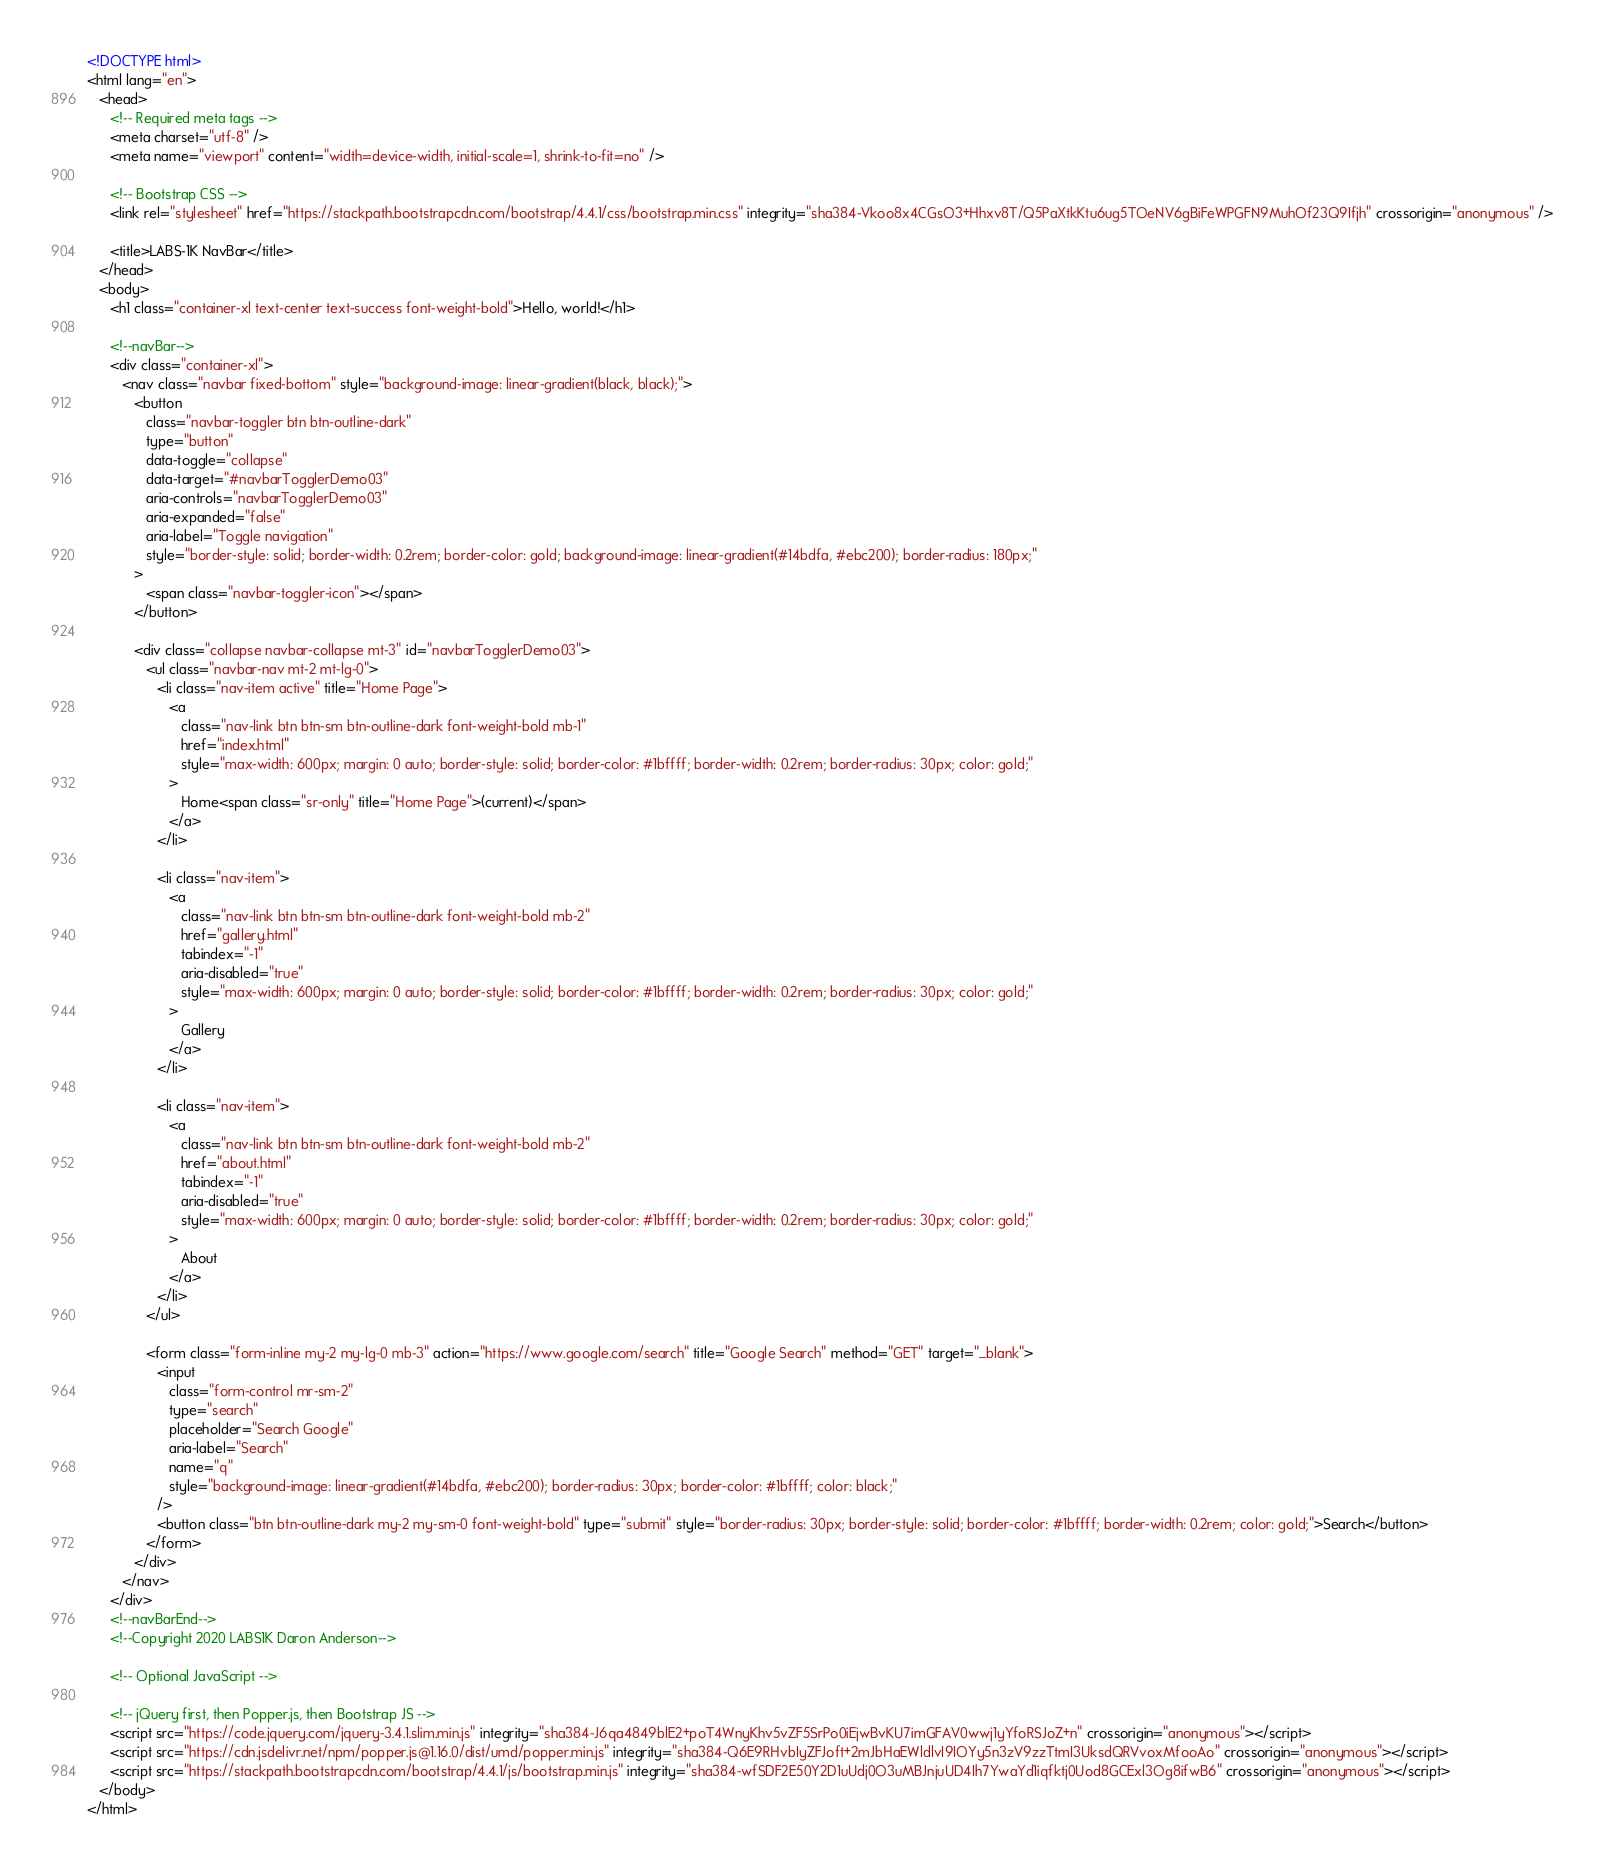Convert code to text. <code><loc_0><loc_0><loc_500><loc_500><_HTML_><!DOCTYPE html>
<html lang="en">
   <head>
      <!-- Required meta tags -->
      <meta charset="utf-8" />
      <meta name="viewport" content="width=device-width, initial-scale=1, shrink-to-fit=no" />

      <!-- Bootstrap CSS -->
      <link rel="stylesheet" href="https://stackpath.bootstrapcdn.com/bootstrap/4.4.1/css/bootstrap.min.css" integrity="sha384-Vkoo8x4CGsO3+Hhxv8T/Q5PaXtkKtu6ug5TOeNV6gBiFeWPGFN9MuhOf23Q9Ifjh" crossorigin="anonymous" />

      <title>LABS-1K NavBar</title>
   </head>
   <body>
      <h1 class="container-xl text-center text-success font-weight-bold">Hello, world!</h1>

      <!--navBar-->
      <div class="container-xl">
         <nav class="navbar fixed-bottom" style="background-image: linear-gradient(black, black);">
            <button
               class="navbar-toggler btn btn-outline-dark"
               type="button"
               data-toggle="collapse"
               data-target="#navbarTogglerDemo03"
               aria-controls="navbarTogglerDemo03"
               aria-expanded="false"
               aria-label="Toggle navigation"
               style="border-style: solid; border-width: 0.2rem; border-color: gold; background-image: linear-gradient(#14bdfa, #ebc200); border-radius: 180px;"
            >
               <span class="navbar-toggler-icon"></span>
            </button>

            <div class="collapse navbar-collapse mt-3" id="navbarTogglerDemo03">
               <ul class="navbar-nav mt-2 mt-lg-0">
                  <li class="nav-item active" title="Home Page">
                     <a
                        class="nav-link btn btn-sm btn-outline-dark font-weight-bold mb-1"
                        href="index.html"
                        style="max-width: 600px; margin: 0 auto; border-style: solid; border-color: #1bffff; border-width: 0.2rem; border-radius: 30px; color: gold;"
                     >
                        Home<span class="sr-only" title="Home Page">(current)</span>
                     </a>
                  </li>

                  <li class="nav-item">
                     <a
                        class="nav-link btn btn-sm btn-outline-dark font-weight-bold mb-2"
                        href="gallery.html"
                        tabindex="-1"
                        aria-disabled="true"
                        style="max-width: 600px; margin: 0 auto; border-style: solid; border-color: #1bffff; border-width: 0.2rem; border-radius: 30px; color: gold;"
                     >
                        Gallery
                     </a>
                  </li>

                  <li class="nav-item">
                     <a
                        class="nav-link btn btn-sm btn-outline-dark font-weight-bold mb-2"
                        href="about.html"
                        tabindex="-1"
                        aria-disabled="true"
                        style="max-width: 600px; margin: 0 auto; border-style: solid; border-color: #1bffff; border-width: 0.2rem; border-radius: 30px; color: gold;"
                     >
                        About
                     </a>
                  </li>
               </ul>

               <form class="form-inline my-2 my-lg-0 mb-3" action="https://www.google.com/search" title="Google Search" method="GET" target="_blank">
                  <input
                     class="form-control mr-sm-2"
                     type="search"
                     placeholder="Search Google"
                     aria-label="Search"
                     name="q"
                     style="background-image: linear-gradient(#14bdfa, #ebc200); border-radius: 30px; border-color: #1bffff; color: black;"
                  />
                  <button class="btn btn-outline-dark my-2 my-sm-0 font-weight-bold" type="submit" style="border-radius: 30px; border-style: solid; border-color: #1bffff; border-width: 0.2rem; color: gold;">Search</button>
               </form>
            </div>
         </nav>
      </div>
      <!--navBarEnd-->
      <!--Copyright 2020 LABS1K Daron Anderson-->

      <!-- Optional JavaScript -->
         
      <!-- jQuery first, then Popper.js, then Bootstrap JS -->
      <script src="https://code.jquery.com/jquery-3.4.1.slim.min.js" integrity="sha384-J6qa4849blE2+poT4WnyKhv5vZF5SrPo0iEjwBvKU7imGFAV0wwj1yYfoRSJoZ+n" crossorigin="anonymous"></script>
      <script src="https://cdn.jsdelivr.net/npm/popper.js@1.16.0/dist/umd/popper.min.js" integrity="sha384-Q6E9RHvbIyZFJoft+2mJbHaEWldlvI9IOYy5n3zV9zzTtmI3UksdQRVvoxMfooAo" crossorigin="anonymous"></script>
      <script src="https://stackpath.bootstrapcdn.com/bootstrap/4.4.1/js/bootstrap.min.js" integrity="sha384-wfSDF2E50Y2D1uUdj0O3uMBJnjuUD4Ih7YwaYd1iqfktj0Uod8GCExl3Og8ifwB6" crossorigin="anonymous"></script>
   </body>
</html>
</code> 